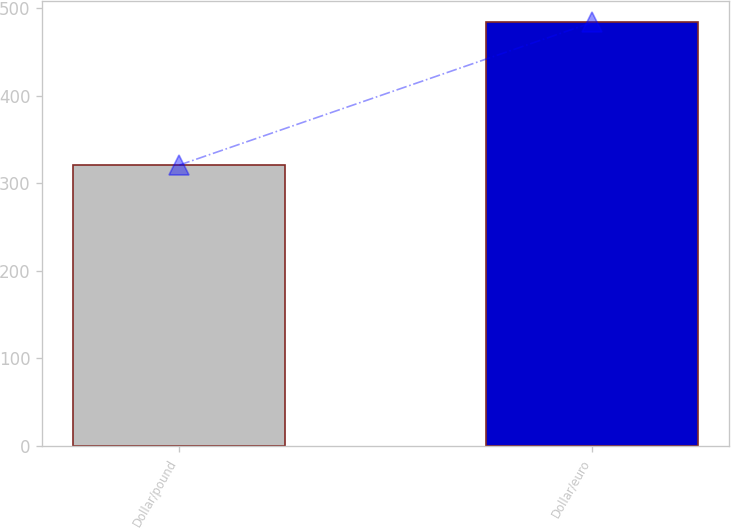Convert chart to OTSL. <chart><loc_0><loc_0><loc_500><loc_500><bar_chart><fcel>Dollar/pound<fcel>Dollar/euro<nl><fcel>321<fcel>484<nl></chart> 